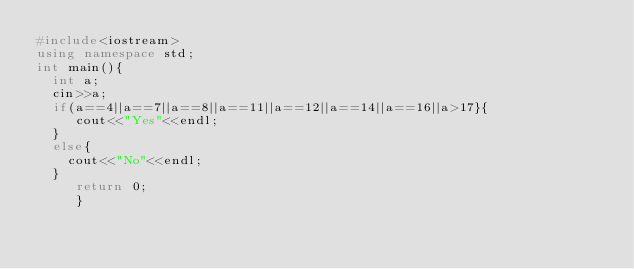<code> <loc_0><loc_0><loc_500><loc_500><_C++_>#include<iostream>
using namespace std;
int main(){
  int a;
  cin>>a;
  if(a==4||a==7||a==8||a==11||a==12||a==14||a==16||a>17}{
     cout<<"Yes"<<endl;
  }
  else{
    cout<<"No"<<endl;
  }
     return 0;
     }</code> 